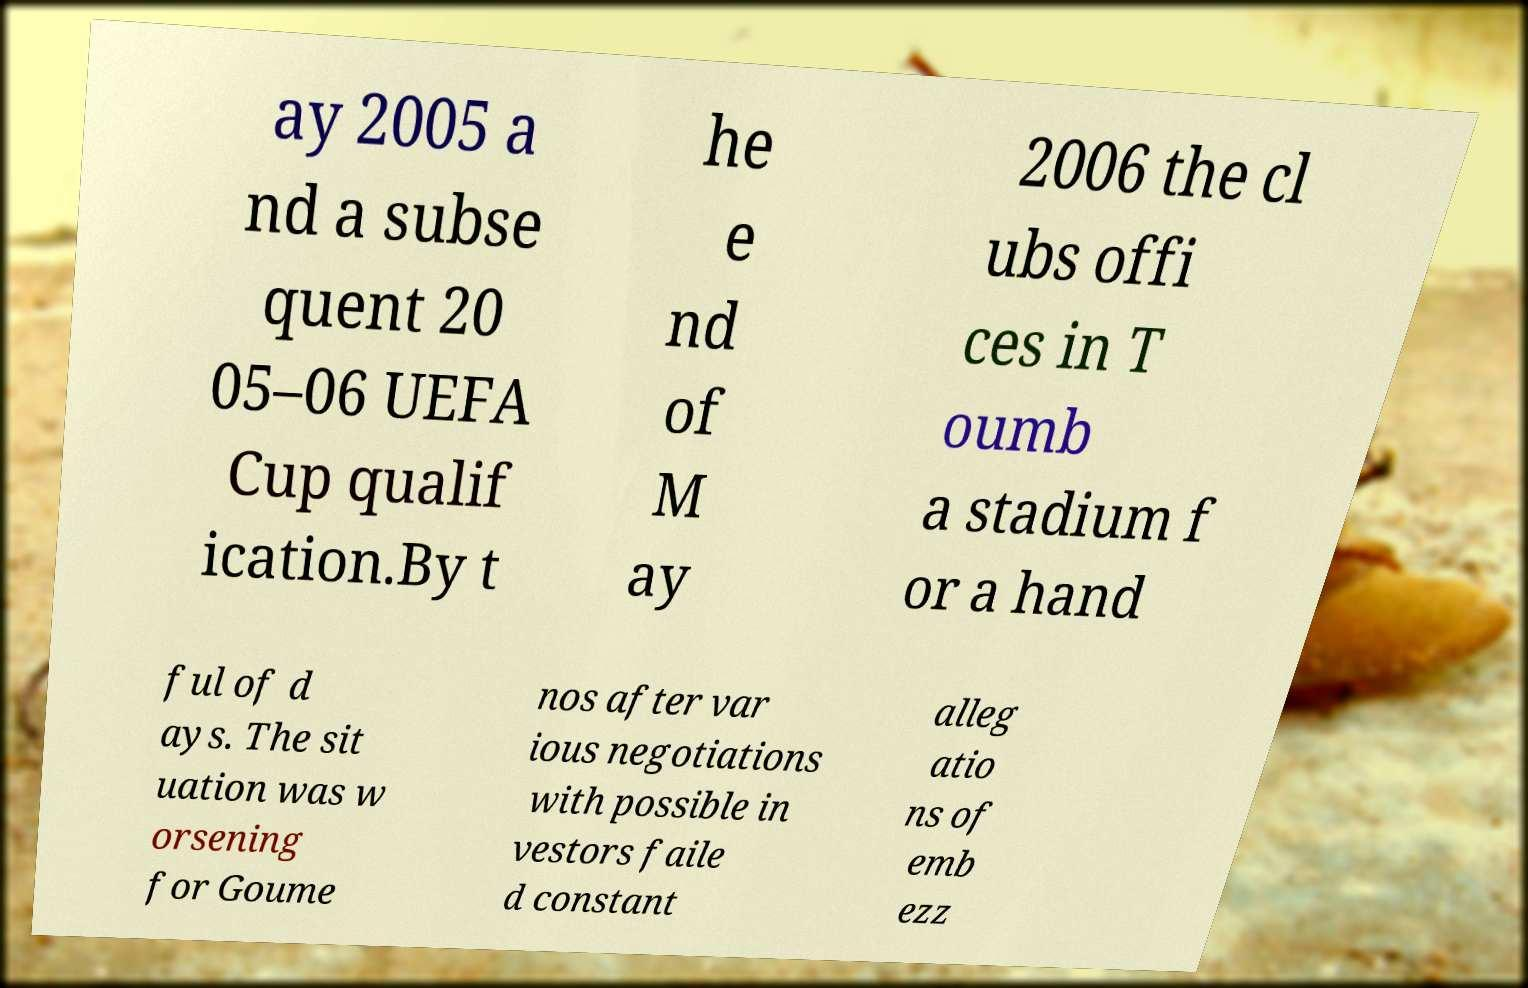There's text embedded in this image that I need extracted. Can you transcribe it verbatim? ay 2005 a nd a subse quent 20 05–06 UEFA Cup qualif ication.By t he e nd of M ay 2006 the cl ubs offi ces in T oumb a stadium f or a hand ful of d ays. The sit uation was w orsening for Goume nos after var ious negotiations with possible in vestors faile d constant alleg atio ns of emb ezz 